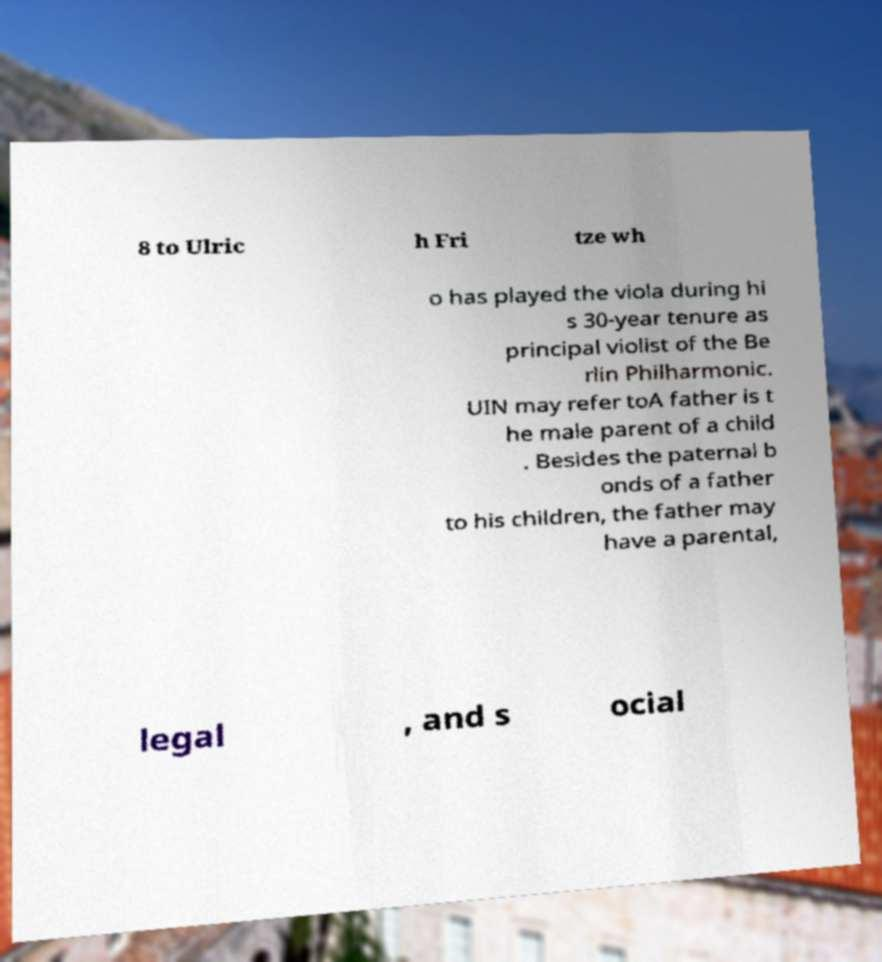What messages or text are displayed in this image? I need them in a readable, typed format. 8 to Ulric h Fri tze wh o has played the viola during hi s 30-year tenure as principal violist of the Be rlin Philharmonic. UIN may refer toA father is t he male parent of a child . Besides the paternal b onds of a father to his children, the father may have a parental, legal , and s ocial 